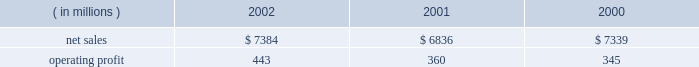Lockheed martin corporation management 2019s discussion and analysis of financial condition and results of operations december 31 , 2002 space systems space systems 2019 operating results included the following : ( in millions ) 2002 2001 2000 .
Net sales for space systems increased by 8% ( 8 % ) in 2002 compared to 2001 .
The increase in sales for 2002 resulted from higher volume in government space of $ 370 million and commercial space of $ 180 million .
In government space , increases of $ 470 million in government satellite programs and $ 130 million in ground systems activities more than offset volume declines of $ 175 million on government launch vehi- cles and $ 55 million on strategic missile programs .
The increase in commercial space sales is primarily attributable to an increase in launch vehicle activities , with nine commercial launches during 2002 compared to six in 2001 .
Net sales for the segment decreased by 7% ( 7 % ) in 2001 com- pared to 2000 .
The decrease in sales for 2001 resulted from volume declines in commercial space of $ 560 million , which more than offset increases in government space of $ 60 million .
In commercial space , sales declined due to volume reductions of $ 480 million in commercial launch vehicle activities and $ 80 million in satellite programs .
There were six launches in 2001 compared to 14 launches in 2000 .
The increase in gov- ernment space resulted from a combined increase of $ 230 mil- lion related to higher volume on government satellite programs and ground systems activities .
These increases were partially offset by a $ 110 million decrease related to volume declines in government launch vehicle activity , primarily due to program maturities , and by $ 50 million due to the absence in 2001 of favorable adjustments recorded on the titan iv pro- gram in 2000 .
Operating profit for the segment increased 23% ( 23 % ) in 2002 as compared to 2001 , mainly driven by the commercial space business .
Reduced losses in commercial space during 2002 resulted in increased operating profit of $ 90 million when compared to 2001 .
Commercial satellite manufacturing losses declined $ 100 million in 2002 as operating performance improved and satellite deliveries increased .
In the first quarter of 2001 , a $ 40 million loss provision was recorded on certain commercial satellite manufacturing contracts .
Due to the industry-wide oversupply and deterioration of pricing in the commercial launch market , financial results on commercial launch vehicles continue to be challenging .
During 2002 , this trend led to a decline in operating profit of $ 10 million on commercial launch vehicles when compared to 2001 .
This decrease was primarily due to lower profitability of $ 55 mil- lion on the three additional launches in the current year , addi- tional charges of $ 60 million ( net of a favorable contract adjustment of $ 20 million ) for market and pricing pressures and included the adverse effect of a $ 35 million adjustment for commercial launch vehicle contract settlement costs .
The 2001 results also included charges for market and pricing pressures , which reduced that year 2019s operating profit by $ 145 million .
The $ 10 million decrease in government space 2019s operating profit for the year is primarily due to the reduced volume on government launch vehicles and strategic missile programs , which combined to decrease operating profit by $ 80 million , partially offset by increases of $ 40 million in government satellite programs and $ 30 million in ground systems activities .
Operating profit for the segment increased by 4% ( 4 % ) in 2001 compared to 2000 .
Operating profit increased in 2001 due to a $ 35 million increase in government space partially offset by higher year-over-year losses of $ 20 million in commercial space .
In government space , operating profit increased due to the impact of higher volume and improved performance in ground systems and government satellite programs .
The year- to-year comparison of operating profit was not affected by the $ 50 million favorable titan iv adjustment recorded in 2000 discussed above , due to a $ 55 million charge related to a more conservative assessment of government launch vehi- cle programs that was recorded in the fourth quarter of 2000 .
In commercial space , decreased operating profit of $ 15 mil- lion on launch vehicles more than offset lower losses on satel- lite manufacturing activities .
The commercial launch vehicle operating results included $ 60 million in higher charges for market and pricing pressures when compared to 2000 .
These negative adjustments were partially offset by $ 50 million of favorable contract adjustments on certain launch vehicle con- tracts .
Commercial satellite manufacturing losses decreased slightly from 2000 and included the adverse impact of a $ 40 million loss provision recorded in the first quarter of 2001 for certain commercial satellite contracts related to schedule and technical issues. .
What was the operating margin for space systems in 2002? 
Computations: (443 / 7384)
Answer: 0.05999. 